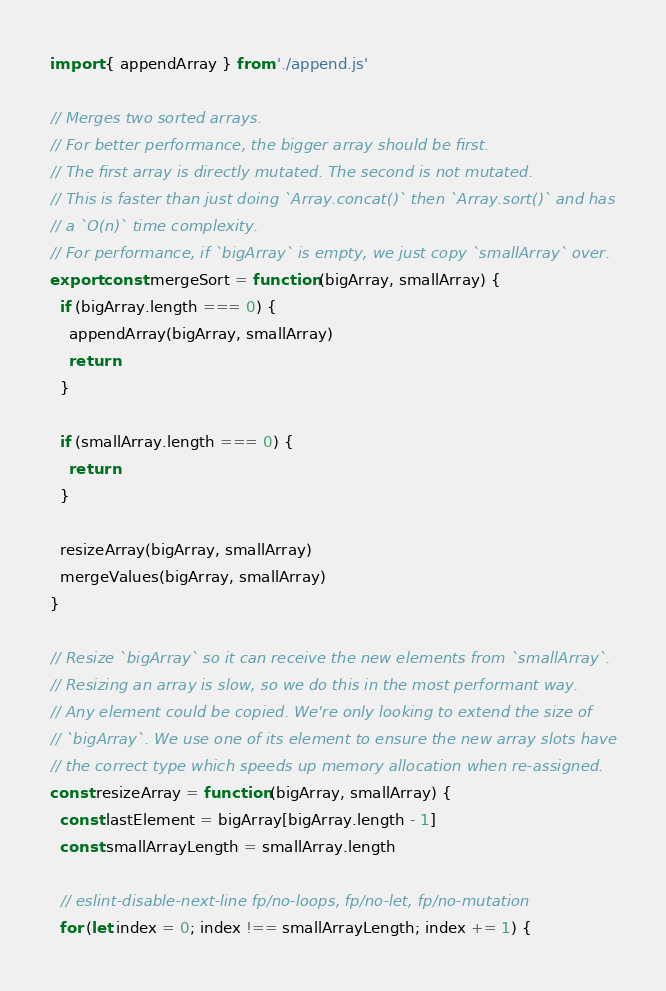<code> <loc_0><loc_0><loc_500><loc_500><_JavaScript_>import { appendArray } from './append.js'

// Merges two sorted arrays.
// For better performance, the bigger array should be first.
// The first array is directly mutated. The second is not mutated.
// This is faster than just doing `Array.concat()` then `Array.sort()` and has
// a `O(n)` time complexity.
// For performance, if `bigArray` is empty, we just copy `smallArray` over.
export const mergeSort = function (bigArray, smallArray) {
  if (bigArray.length === 0) {
    appendArray(bigArray, smallArray)
    return
  }

  if (smallArray.length === 0) {
    return
  }

  resizeArray(bigArray, smallArray)
  mergeValues(bigArray, smallArray)
}

// Resize `bigArray` so it can receive the new elements from `smallArray`.
// Resizing an array is slow, so we do this in the most performant way.
// Any element could be copied. We're only looking to extend the size of
// `bigArray`. We use one of its element to ensure the new array slots have
// the correct type which speeds up memory allocation when re-assigned.
const resizeArray = function (bigArray, smallArray) {
  const lastElement = bigArray[bigArray.length - 1]
  const smallArrayLength = smallArray.length

  // eslint-disable-next-line fp/no-loops, fp/no-let, fp/no-mutation
  for (let index = 0; index !== smallArrayLength; index += 1) {</code> 